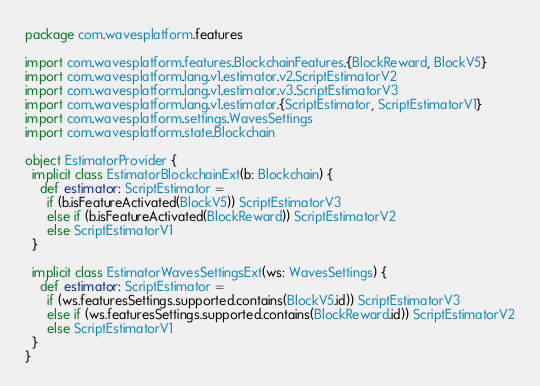<code> <loc_0><loc_0><loc_500><loc_500><_Scala_>package com.wavesplatform.features

import com.wavesplatform.features.BlockchainFeatures.{BlockReward, BlockV5}
import com.wavesplatform.lang.v1.estimator.v2.ScriptEstimatorV2
import com.wavesplatform.lang.v1.estimator.v3.ScriptEstimatorV3
import com.wavesplatform.lang.v1.estimator.{ScriptEstimator, ScriptEstimatorV1}
import com.wavesplatform.settings.WavesSettings
import com.wavesplatform.state.Blockchain

object EstimatorProvider {
  implicit class EstimatorBlockchainExt(b: Blockchain) {
    def estimator: ScriptEstimator =
      if (b.isFeatureActivated(BlockV5)) ScriptEstimatorV3
      else if (b.isFeatureActivated(BlockReward)) ScriptEstimatorV2
      else ScriptEstimatorV1
  }

  implicit class EstimatorWavesSettingsExt(ws: WavesSettings) {
    def estimator: ScriptEstimator =
      if (ws.featuresSettings.supported.contains(BlockV5.id)) ScriptEstimatorV3
      else if (ws.featuresSettings.supported.contains(BlockReward.id)) ScriptEstimatorV2
      else ScriptEstimatorV1
  }
}
</code> 